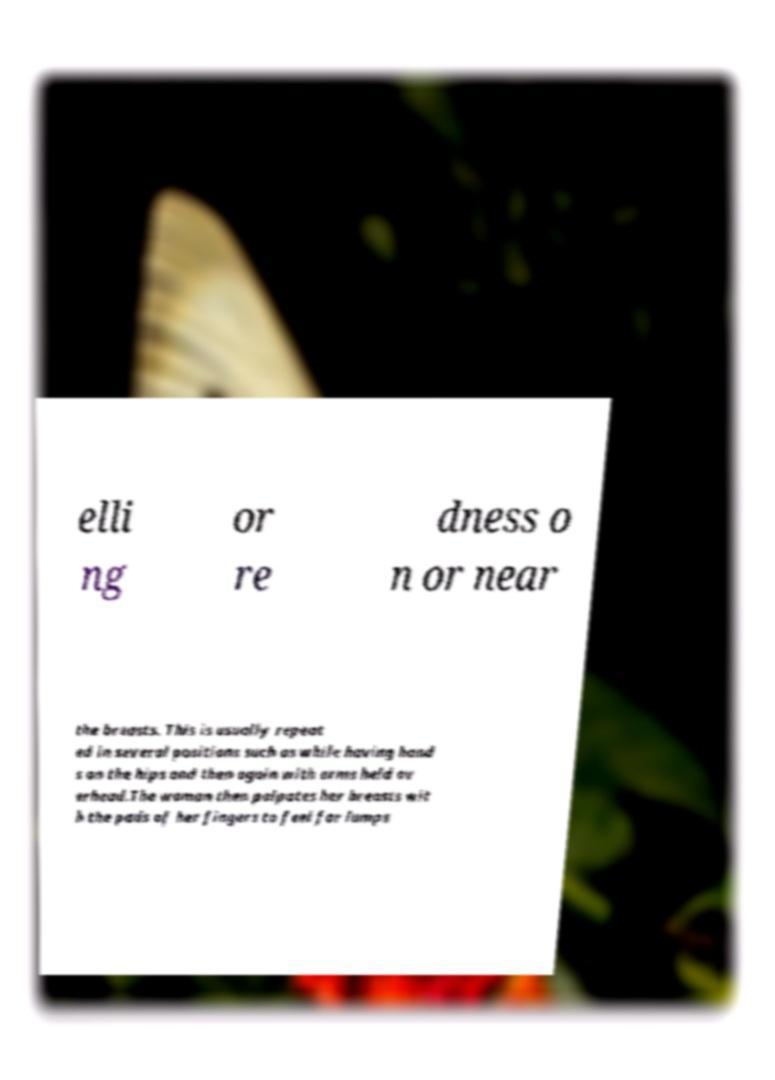Please identify and transcribe the text found in this image. elli ng or re dness o n or near the breasts. This is usually repeat ed in several positions such as while having hand s on the hips and then again with arms held ov erhead.The woman then palpates her breasts wit h the pads of her fingers to feel for lumps 